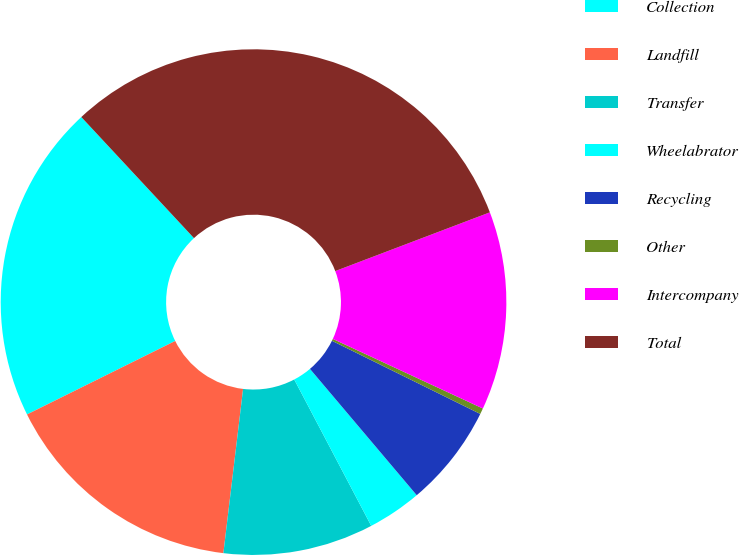Convert chart. <chart><loc_0><loc_0><loc_500><loc_500><pie_chart><fcel>Collection<fcel>Landfill<fcel>Transfer<fcel>Wheelabrator<fcel>Recycling<fcel>Other<fcel>Intercompany<fcel>Total<nl><fcel>20.4%<fcel>15.77%<fcel>9.61%<fcel>3.46%<fcel>6.54%<fcel>0.38%<fcel>12.69%<fcel>31.15%<nl></chart> 